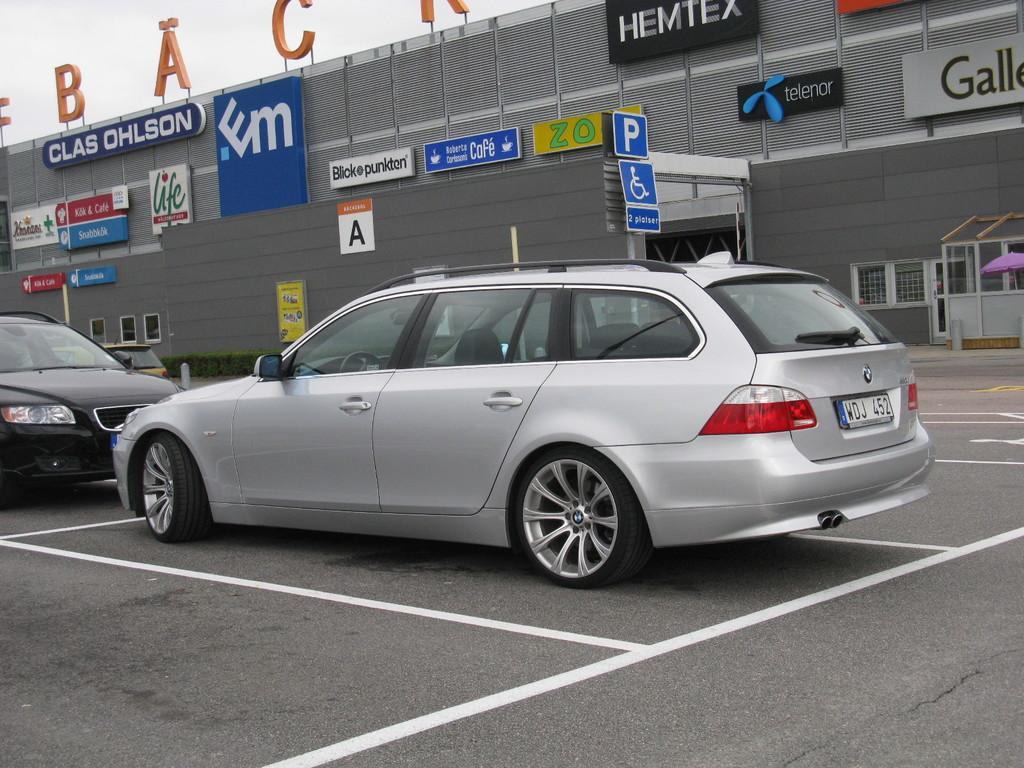<image>
Summarize the visual content of the image. Silver van outside of a building which says "HEMTEX". 